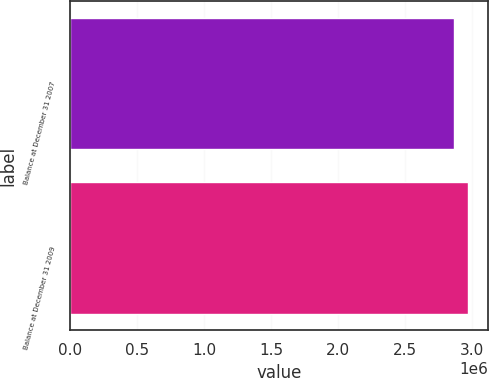Convert chart to OTSL. <chart><loc_0><loc_0><loc_500><loc_500><bar_chart><fcel>Balance at December 31 2007<fcel>Balance at December 31 2009<nl><fcel>2.86174e+06<fcel>2.96786e+06<nl></chart> 